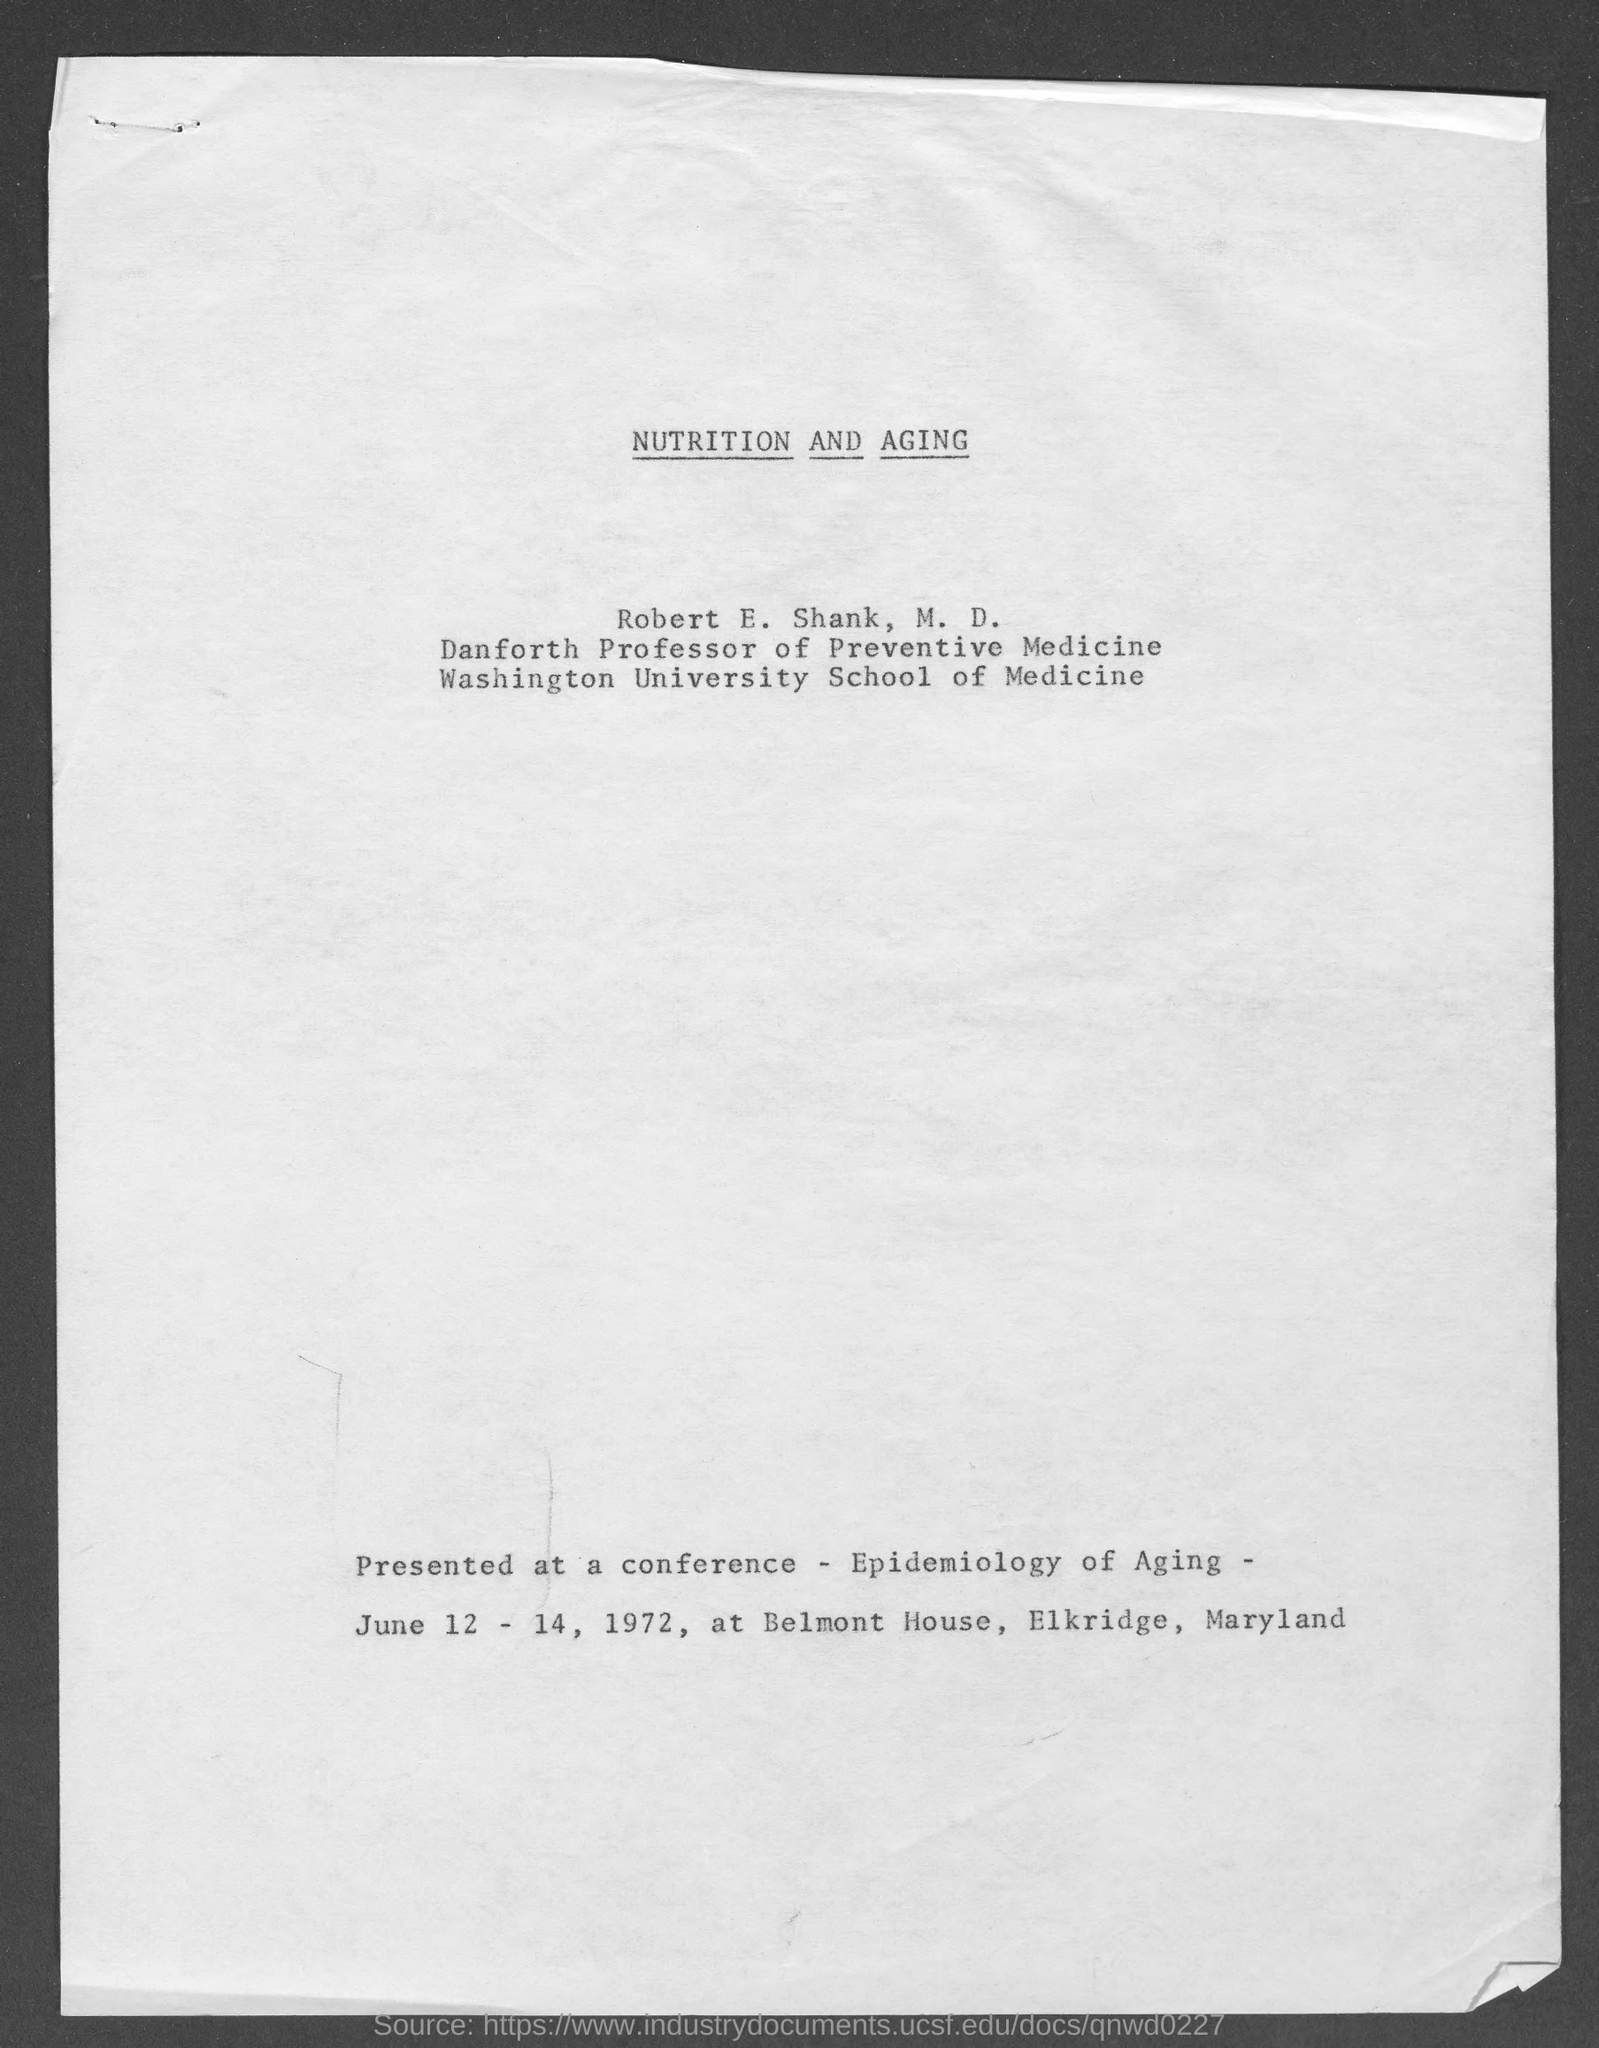Draw attention to some important aspects in this diagram. Robert E. Shank, M.D. holds the designation of Danforth Professor of Preventive Medicine. 